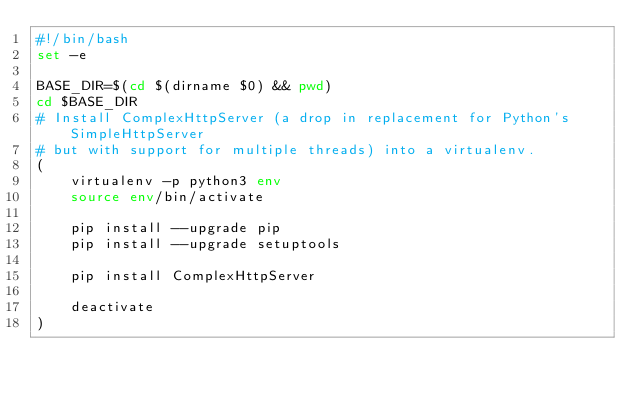<code> <loc_0><loc_0><loc_500><loc_500><_Bash_>#!/bin/bash
set -e

BASE_DIR=$(cd $(dirname $0) && pwd)
cd $BASE_DIR
# Install ComplexHttpServer (a drop in replacement for Python's SimpleHttpServer
# but with support for multiple threads) into a virtualenv.
(
    virtualenv -p python3 env
    source env/bin/activate

    pip install --upgrade pip
    pip install --upgrade setuptools

    pip install ComplexHttpServer

    deactivate
)
</code> 